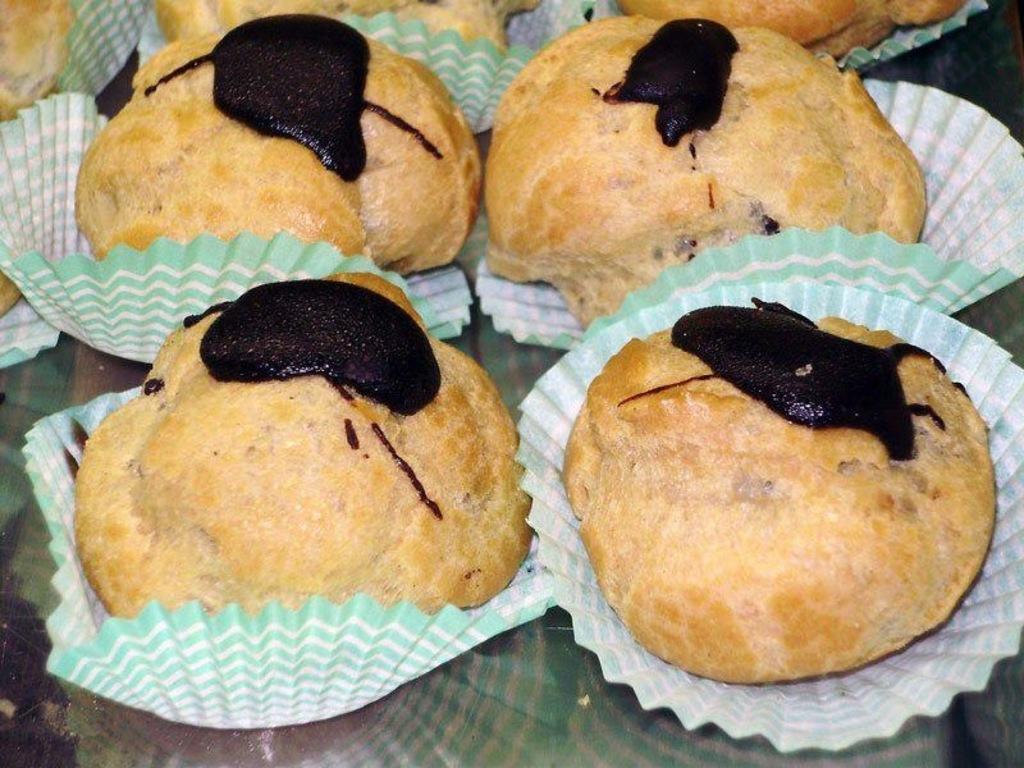How would you summarize this image in a sentence or two? In this image, we can see snacks placed on the table. 